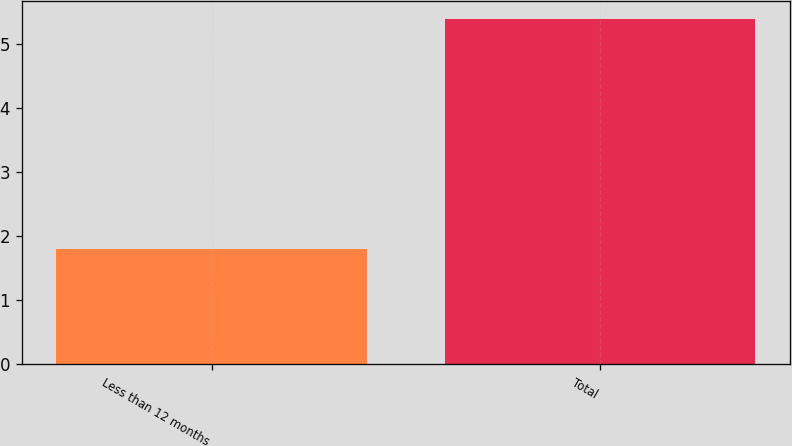<chart> <loc_0><loc_0><loc_500><loc_500><bar_chart><fcel>Less than 12 months<fcel>Total<nl><fcel>1.8<fcel>5.4<nl></chart> 